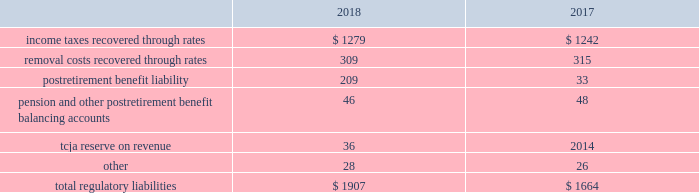Pre-construction costs , interim dam safety measures and environmental costs and construction costs .
The authorized costs were being recovered via a surcharge over a twenty-year period which began in october 2012 .
The unrecovered balance of project costs incurred , including cost of capital , net of surcharges totaled $ 85 million and $ 89 million as of december 31 , 2018 and 2017 , respectively .
Surcharges collected were $ 8 million and $ 7 million for the years ended december 31 , 2018 and 2017 , respectively .
Pursuant to the general rate case approved in december 2018 , approval was granted to reset the twenty-year amortization period to begin january 1 , 2018 and to establish an annual revenue requirement of $ 8 million to be recovered through base rates .
Debt expense is amortized over the lives of the respective issues .
Call premiums on the redemption of long- term debt , as well as unamortized debt expense , are deferred and amortized to the extent they will be recovered through future service rates .
Purchase premium recoverable through rates is primarily the recovery of the acquisition premiums related to an asset acquisition by the company 2019s utility subsidiary in california during 2002 , and acquisitions in 2007 by the company 2019s utility subsidiary in new jersey .
As authorized for recovery by the california and new jersey pucs , these costs are being amortized to depreciation and amortization on the consolidated statements of operations through november 2048 .
Tank painting costs are generally deferred and amortized to operations and maintenance expense on the consolidated statements of operations on a straight-line basis over periods ranging from five to fifteen years , as authorized by the regulatory authorities in their determination of rates charged for service .
As a result of the prepayment by american water capital corp. , the company 2019s wholly owned finance subsidiary ( 201cawcc 201d ) , of the 5.62% ( 5.62 % ) series c senior notes due upon maturity on december 21 , 2018 ( the 201cseries c notes 201d ) , 5.62% ( 5.62 % ) series e senior notes due march 29 , 2019 ( the 201cseries e notes 201d ) and 5.77% ( 5.77 % ) series f senior notes due december 21 , 2022 ( the 201cseries f notes , 201d and together with the series e notes , the 201cseries notes 201d ) , a make-whole premium of $ 10 million was paid to the holders of the series notes on september 11 , 2018 .
Substantially all of these early debt extinguishment costs were allocable to the company 2019s utility subsidiaries and recorded as regulatory assets , as the company believes they are probable of recovery in future rates .
Other regulatory assets include certain construction costs for treatment facilities , property tax stabilization , employee-related costs , deferred other postretirement benefit expense , business services project expenses , coastal water project costs , rate case expenditures and environmental remediation costs among others .
These costs are deferred because the amounts are being recovered in rates or are probable of recovery through rates in future periods .
Regulatory liabilities regulatory liabilities generally represent amounts that are probable of being credited or refunded to customers through the rate-making process .
Also , if costs expected to be incurred in the future are currently being recovered through rates , the company records those expected future costs as regulatory liabilities .
The table provides the composition of regulatory liabilities as of december 31: .

By how much did total regulatory liabilities increase from 2017 to 2018? 
Computations: ((1907 - 1664) / 1664)
Answer: 0.14603. 